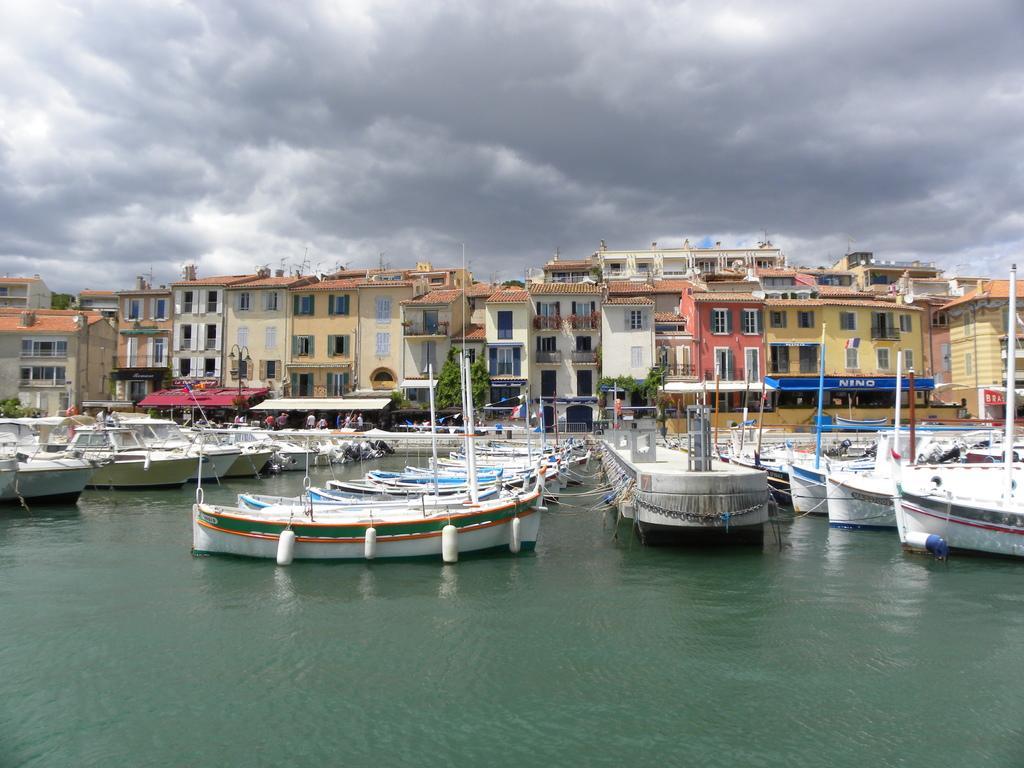In one or two sentences, can you explain what this image depicts? In this image there are buildings and trees, in front of them there are ships and boats on the river. In the background there is the sky. 